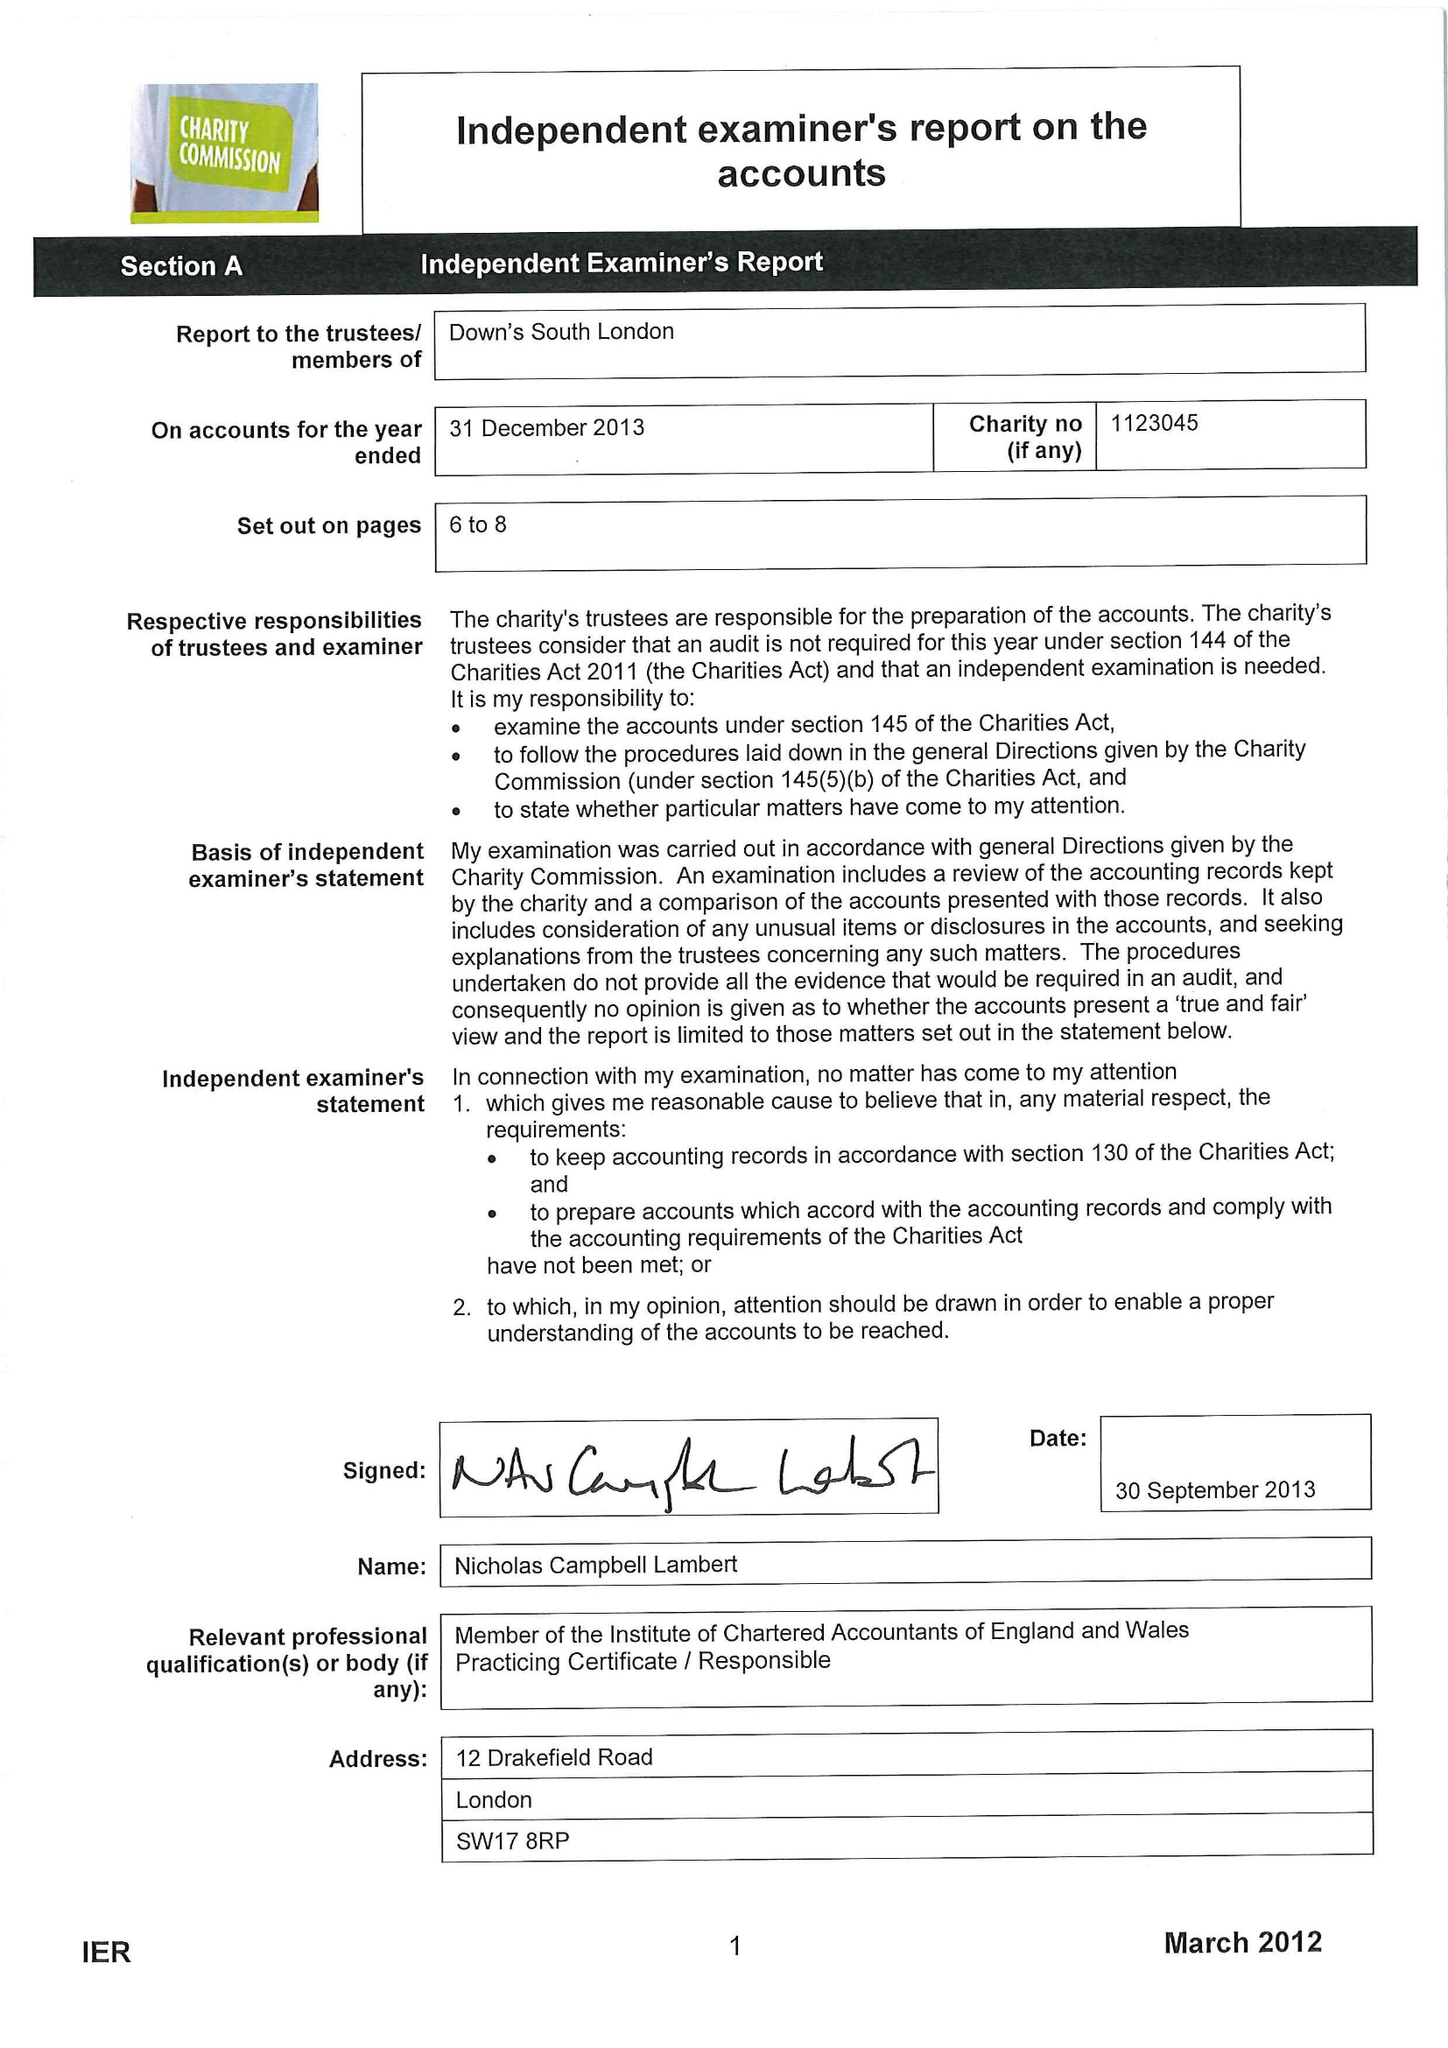What is the value for the charity_name?
Answer the question using a single word or phrase. Down's South London 